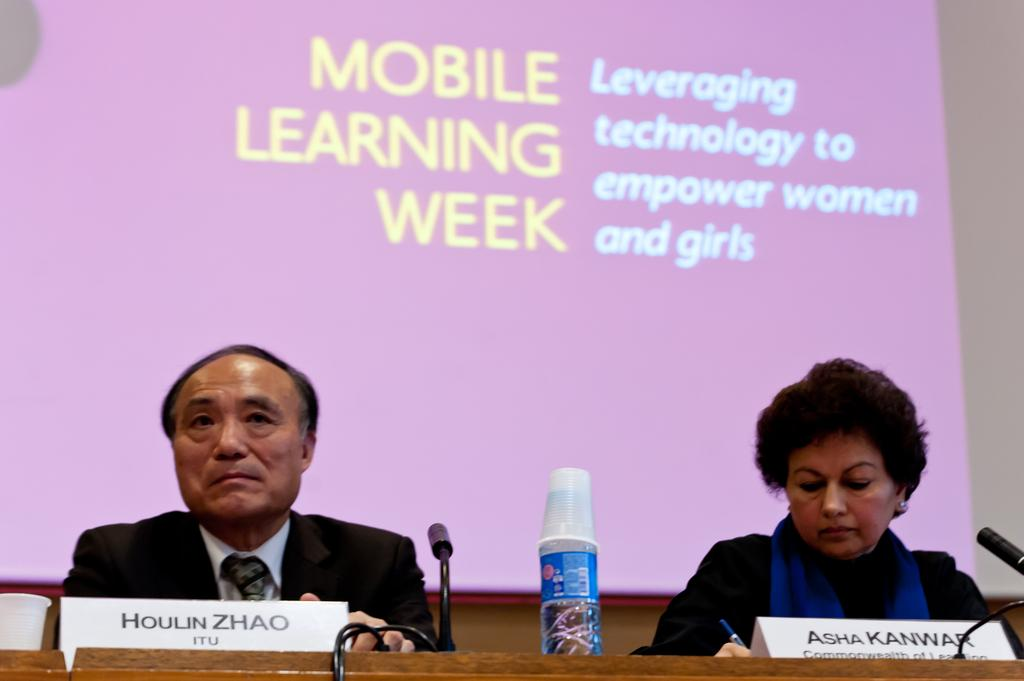<image>
Give a short and clear explanation of the subsequent image. A panel showing a man and woman at a Mobile Learning Week conference to empower women and girls. 